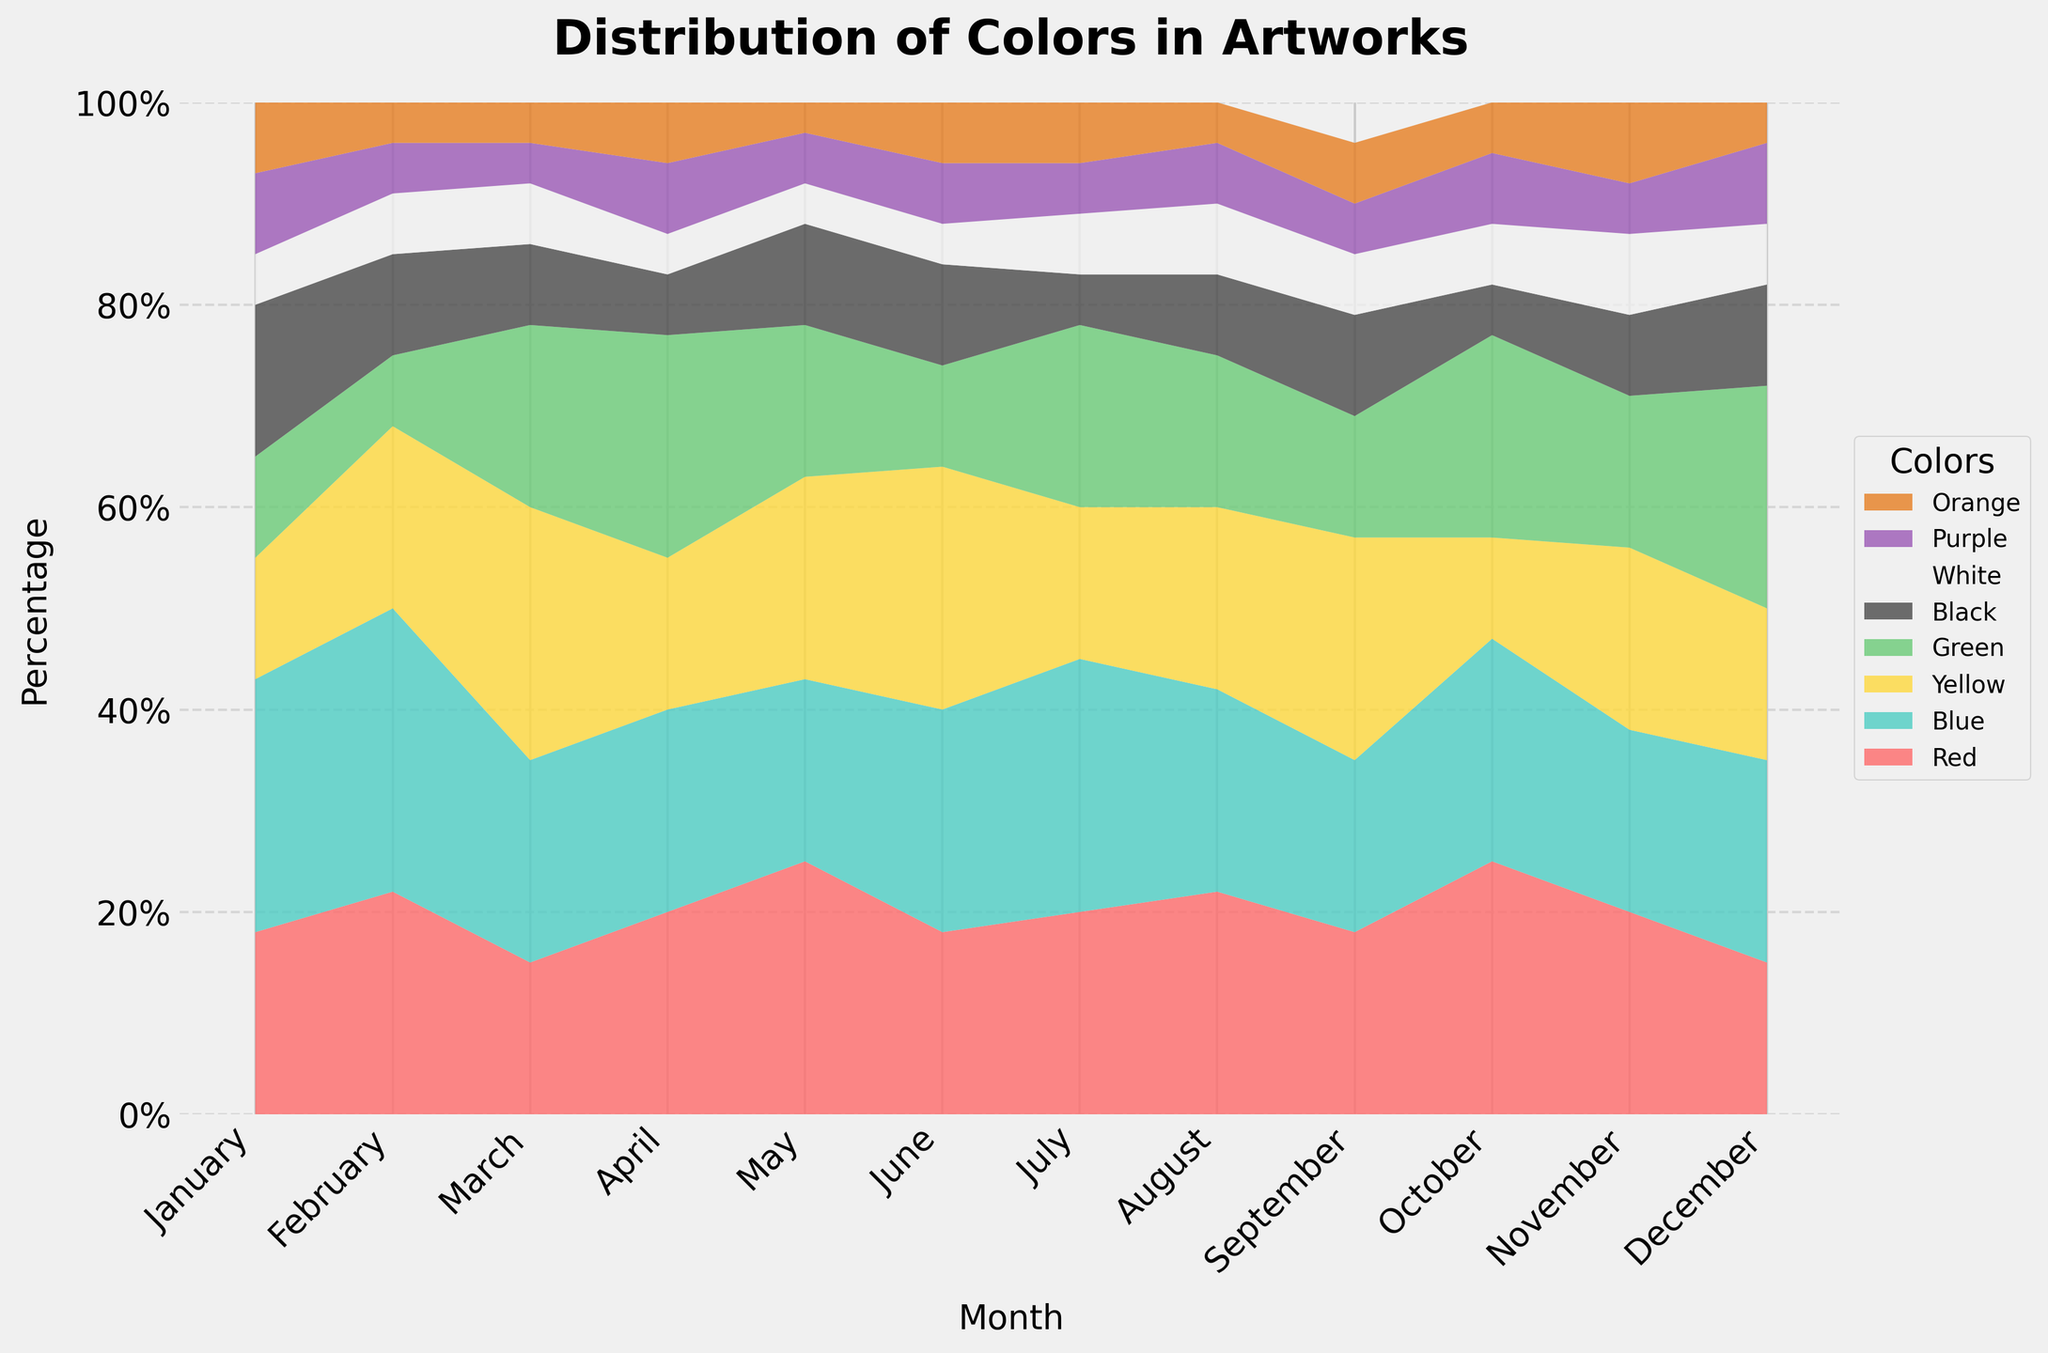which month has the highest percentage of blue used? Look at the area representing the blue section (cyan) in the stacked area chart. Identify the month with the widest section for blue, which is the highest percentage of blue used.
Answer: February how did the percentage of red used change from January to May? Identify the red section in January and compare its height to the red section in May. Calculate the percentage change from January to May.
Answer: Increased which two colors were used the most evenly throughout the year? Examine the width of the sections for each color across all months to see which two colors have the most consistent width throughout the year.
Answer: Blue and White in which month was yellow the dominant color? Find the month where the yellow section is the largest compared to all other colors for that specific month.
Answer: March how does the use of green in April compare to that in December? Compare the height of the green section in April and December to determine if it is higher, lower, or the same.
Answer: Similar which color showed the most variation in its usage throughout the year? Identify the color with the most variability in section height across the months, indicating significant changes in usage over time.
Answer: Yellow what is the trend of black usage over the year? Follow the black section month by month to determine if it is increasing, decreasing, or staying constant over time.
Answer: Decreasing was purple ever the most used color in any month? Check each month to see if the purple section is the highest among all colors.
Answer: No how does the use of white in November compare to its use in July? Compare the height of the white section in November and July, indicating if its percentage increased, decreased, or stayed the same.
Answer: Increased which month has the highest diversity of colors used in artworks? Look for the month where the sections are the most balanced, indicating a wide variety of colors were used without any single color dominating.
Answer: August 